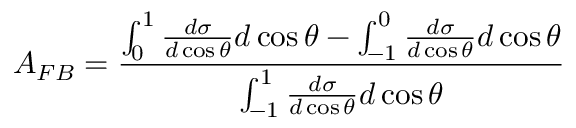<formula> <loc_0><loc_0><loc_500><loc_500>A _ { F B } = \frac { \int _ { 0 } ^ { 1 } \frac { d \sigma } { d \cos { \theta } } d \cos { \theta } - \int _ { - 1 } ^ { 0 } \frac { d \sigma } { d \cos { \theta } } d \cos { \theta } } { \int _ { - 1 } ^ { 1 } \frac { d \sigma } { d \cos { \theta } } d \cos { \theta } }</formula> 